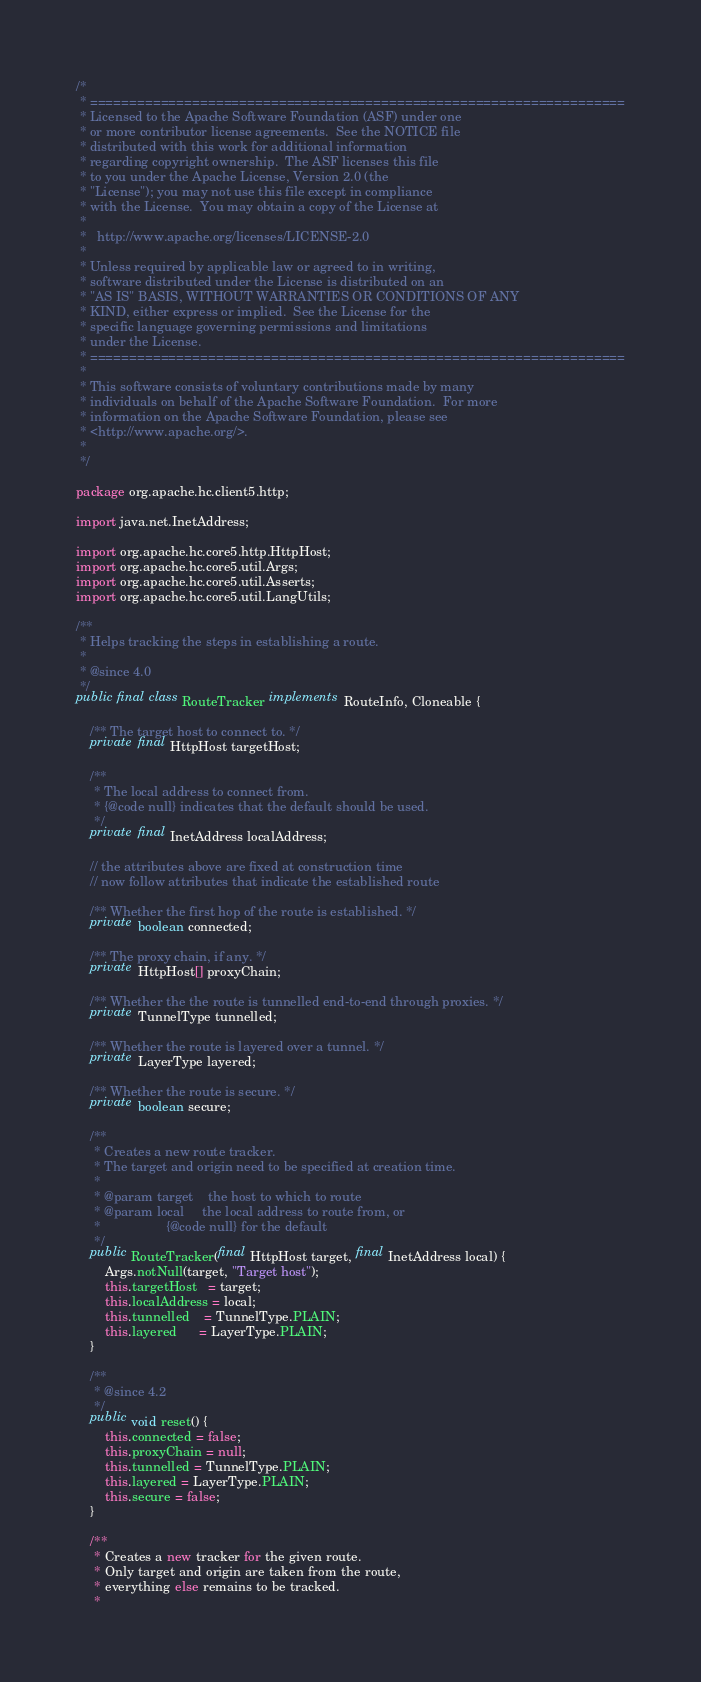Convert code to text. <code><loc_0><loc_0><loc_500><loc_500><_Java_>/*
 * ====================================================================
 * Licensed to the Apache Software Foundation (ASF) under one
 * or more contributor license agreements.  See the NOTICE file
 * distributed with this work for additional information
 * regarding copyright ownership.  The ASF licenses this file
 * to you under the Apache License, Version 2.0 (the
 * "License"); you may not use this file except in compliance
 * with the License.  You may obtain a copy of the License at
 *
 *   http://www.apache.org/licenses/LICENSE-2.0
 *
 * Unless required by applicable law or agreed to in writing,
 * software distributed under the License is distributed on an
 * "AS IS" BASIS, WITHOUT WARRANTIES OR CONDITIONS OF ANY
 * KIND, either express or implied.  See the License for the
 * specific language governing permissions and limitations
 * under the License.
 * ====================================================================
 *
 * This software consists of voluntary contributions made by many
 * individuals on behalf of the Apache Software Foundation.  For more
 * information on the Apache Software Foundation, please see
 * <http://www.apache.org/>.
 *
 */

package org.apache.hc.client5.http;

import java.net.InetAddress;

import org.apache.hc.core5.http.HttpHost;
import org.apache.hc.core5.util.Args;
import org.apache.hc.core5.util.Asserts;
import org.apache.hc.core5.util.LangUtils;

/**
 * Helps tracking the steps in establishing a route.
 *
 * @since 4.0
 */
public final class RouteTracker implements RouteInfo, Cloneable {

    /** The target host to connect to. */
    private final HttpHost targetHost;

    /**
     * The local address to connect from.
     * {@code null} indicates that the default should be used.
     */
    private final InetAddress localAddress;

    // the attributes above are fixed at construction time
    // now follow attributes that indicate the established route

    /** Whether the first hop of the route is established. */
    private boolean connected;

    /** The proxy chain, if any. */
    private HttpHost[] proxyChain;

    /** Whether the the route is tunnelled end-to-end through proxies. */
    private TunnelType tunnelled;

    /** Whether the route is layered over a tunnel. */
    private LayerType layered;

    /** Whether the route is secure. */
    private boolean secure;

    /**
     * Creates a new route tracker.
     * The target and origin need to be specified at creation time.
     *
     * @param target    the host to which to route
     * @param local     the local address to route from, or
     *                  {@code null} for the default
     */
    public RouteTracker(final HttpHost target, final InetAddress local) {
        Args.notNull(target, "Target host");
        this.targetHost   = target;
        this.localAddress = local;
        this.tunnelled    = TunnelType.PLAIN;
        this.layered      = LayerType.PLAIN;
    }

    /**
     * @since 4.2
     */
    public void reset() {
        this.connected = false;
        this.proxyChain = null;
        this.tunnelled = TunnelType.PLAIN;
        this.layered = LayerType.PLAIN;
        this.secure = false;
    }

    /**
     * Creates a new tracker for the given route.
     * Only target and origin are taken from the route,
     * everything else remains to be tracked.
     *</code> 